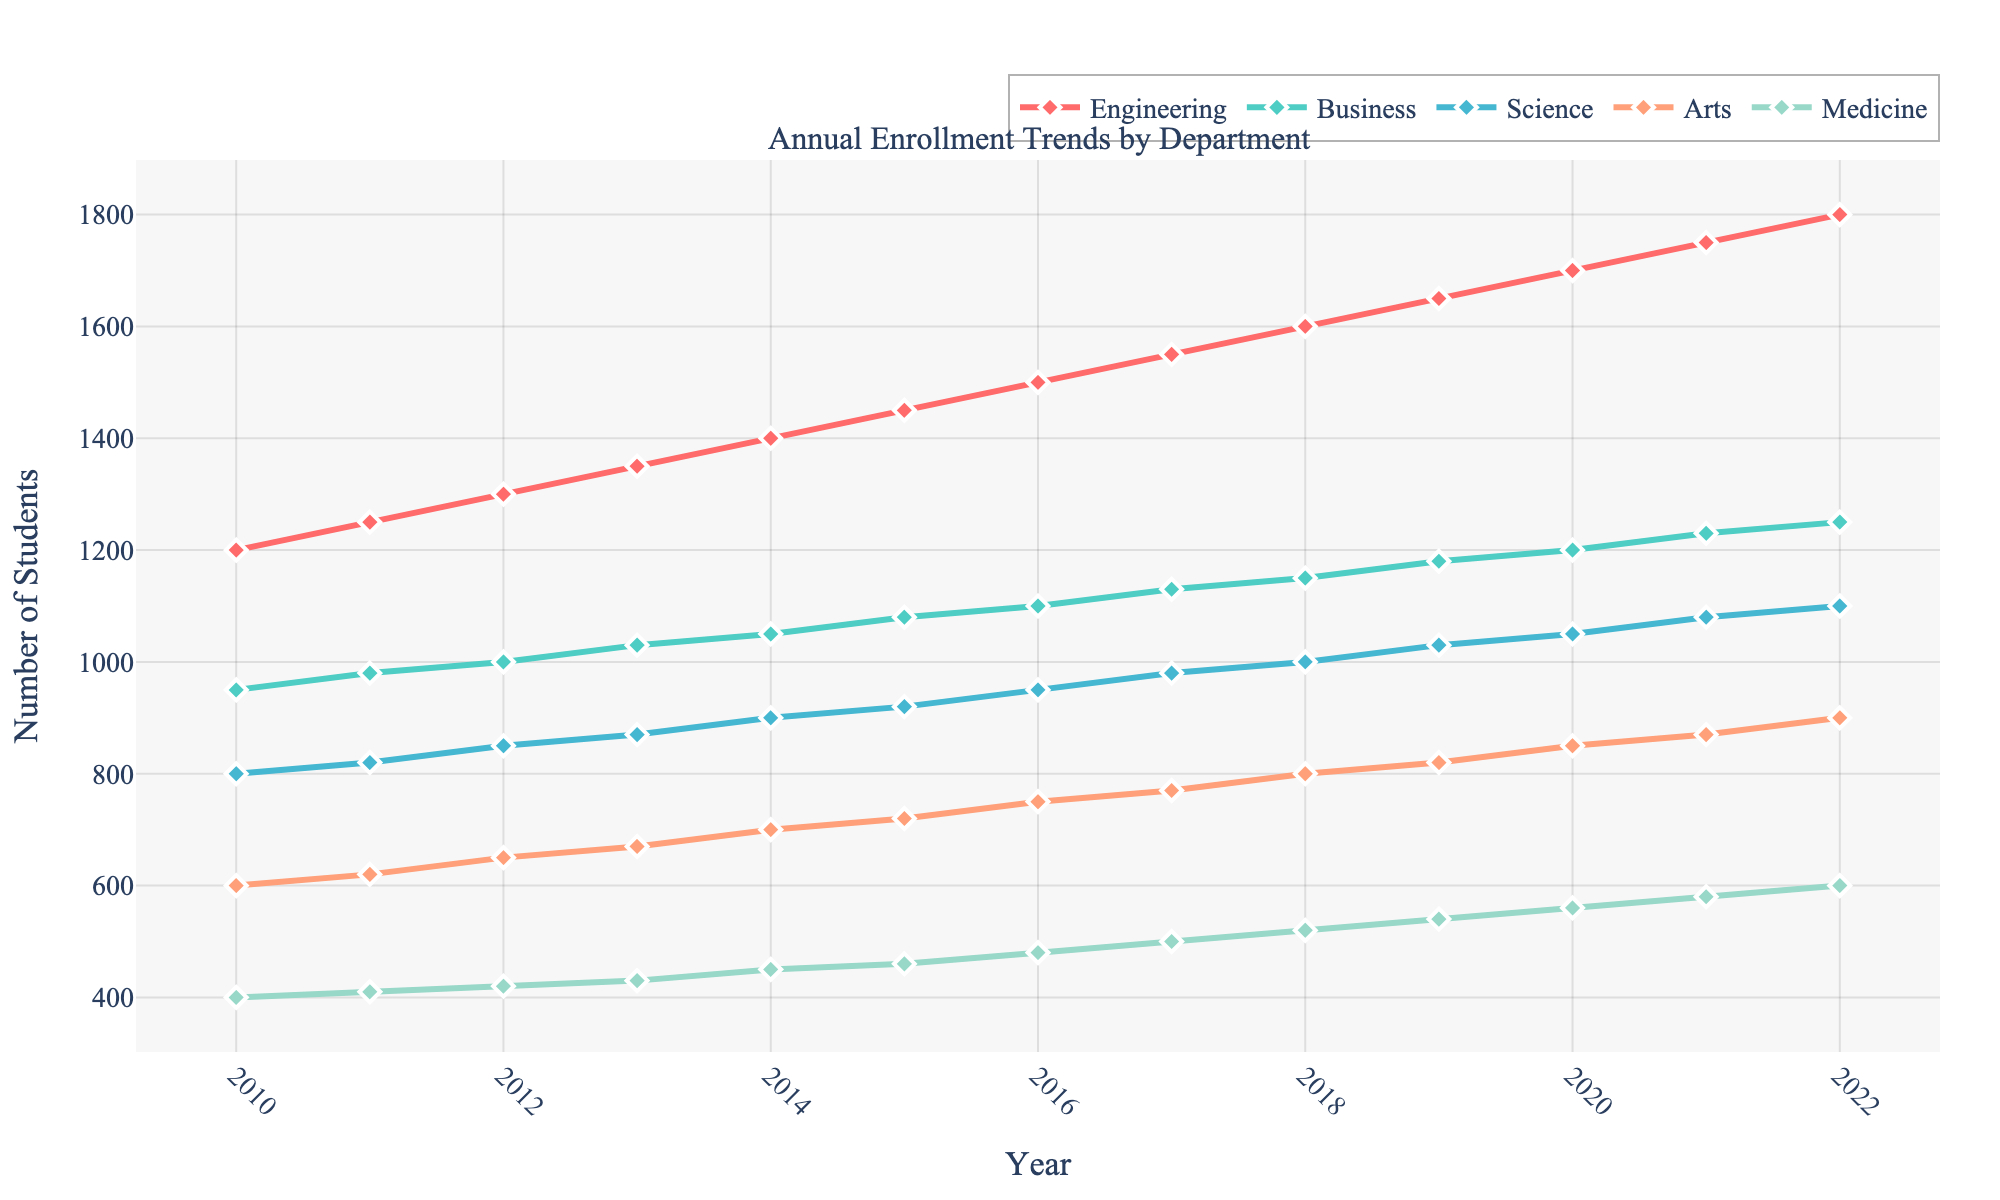Which department had the highest enrollment in 2022? By inspecting the lines at the furthest right (2022), the highest point corresponds to the Engineering department.
Answer: Engineering How did the enrollment numbers change for the Medicine department from 2010 to 2022? The Medicine department had 400 students in 2010, and it increased to 600 students in 2022, showing an increase of 200 over 12 years.
Answer: Increase by 200 Compare the enrollment trends in Business and Science departments over the years. Which one had a consistently higher enrollment? By comparing the lines representing Business and Science across all years, the enrollment for the Business department is consistently higher than that of the Science department.
Answer: Business What is the total increase in student enrollment for the Engineering department from 2010 to 2022? The enrollment in Engineering increased from 1200 in 2010 to 1800 in 2022. Therefore, the total increase is 1800 - 1200 = 600 students.
Answer: 600 In which year did the Arts department experience its largest increase in enrollment compared to the previous year? By examining the line representing the Arts department, the largest increase occurred between 2020 and 2021, where the enrollment increased from 850 to 870, a difference of 20 students.
Answer: 2021 What is the average enrollment in the Science department over the years? Sum of enrollments from 2010 to 2022: 800 + 820 + 850 + 870 + 900 + 920 + 950 + 980 + 1000 + 1030 + 1050 + 1080 + 1100 = 12250. There are 13 years, so the average is 12250 / 13 ≈ 941.
Answer: 941 Which department showed the smallest growth in enrollment over the given period? The smallest growth can be identified by comparing the differences from 2010 to 2022 for all departments. Medicine had the smallest growth, with an increase of just 200 students (400 to 600).
Answer: Medicine How does the enrollment in the Arts department change during the period from 2015 to 2018? The Arts department enrollment increased from 720 in 2015 to 800 in 2018, a difference of 80 students.
Answer: Increase by 80 If you sum the enrollments of all departments for the year 2014, what is the total number of students? The sum for 2014 is 1400 (Engineering) + 1050 (Business) + 900 (Science) + 700 (Arts) + 450 (Medicine), giving a total of 4500 students.
Answer: 4500 